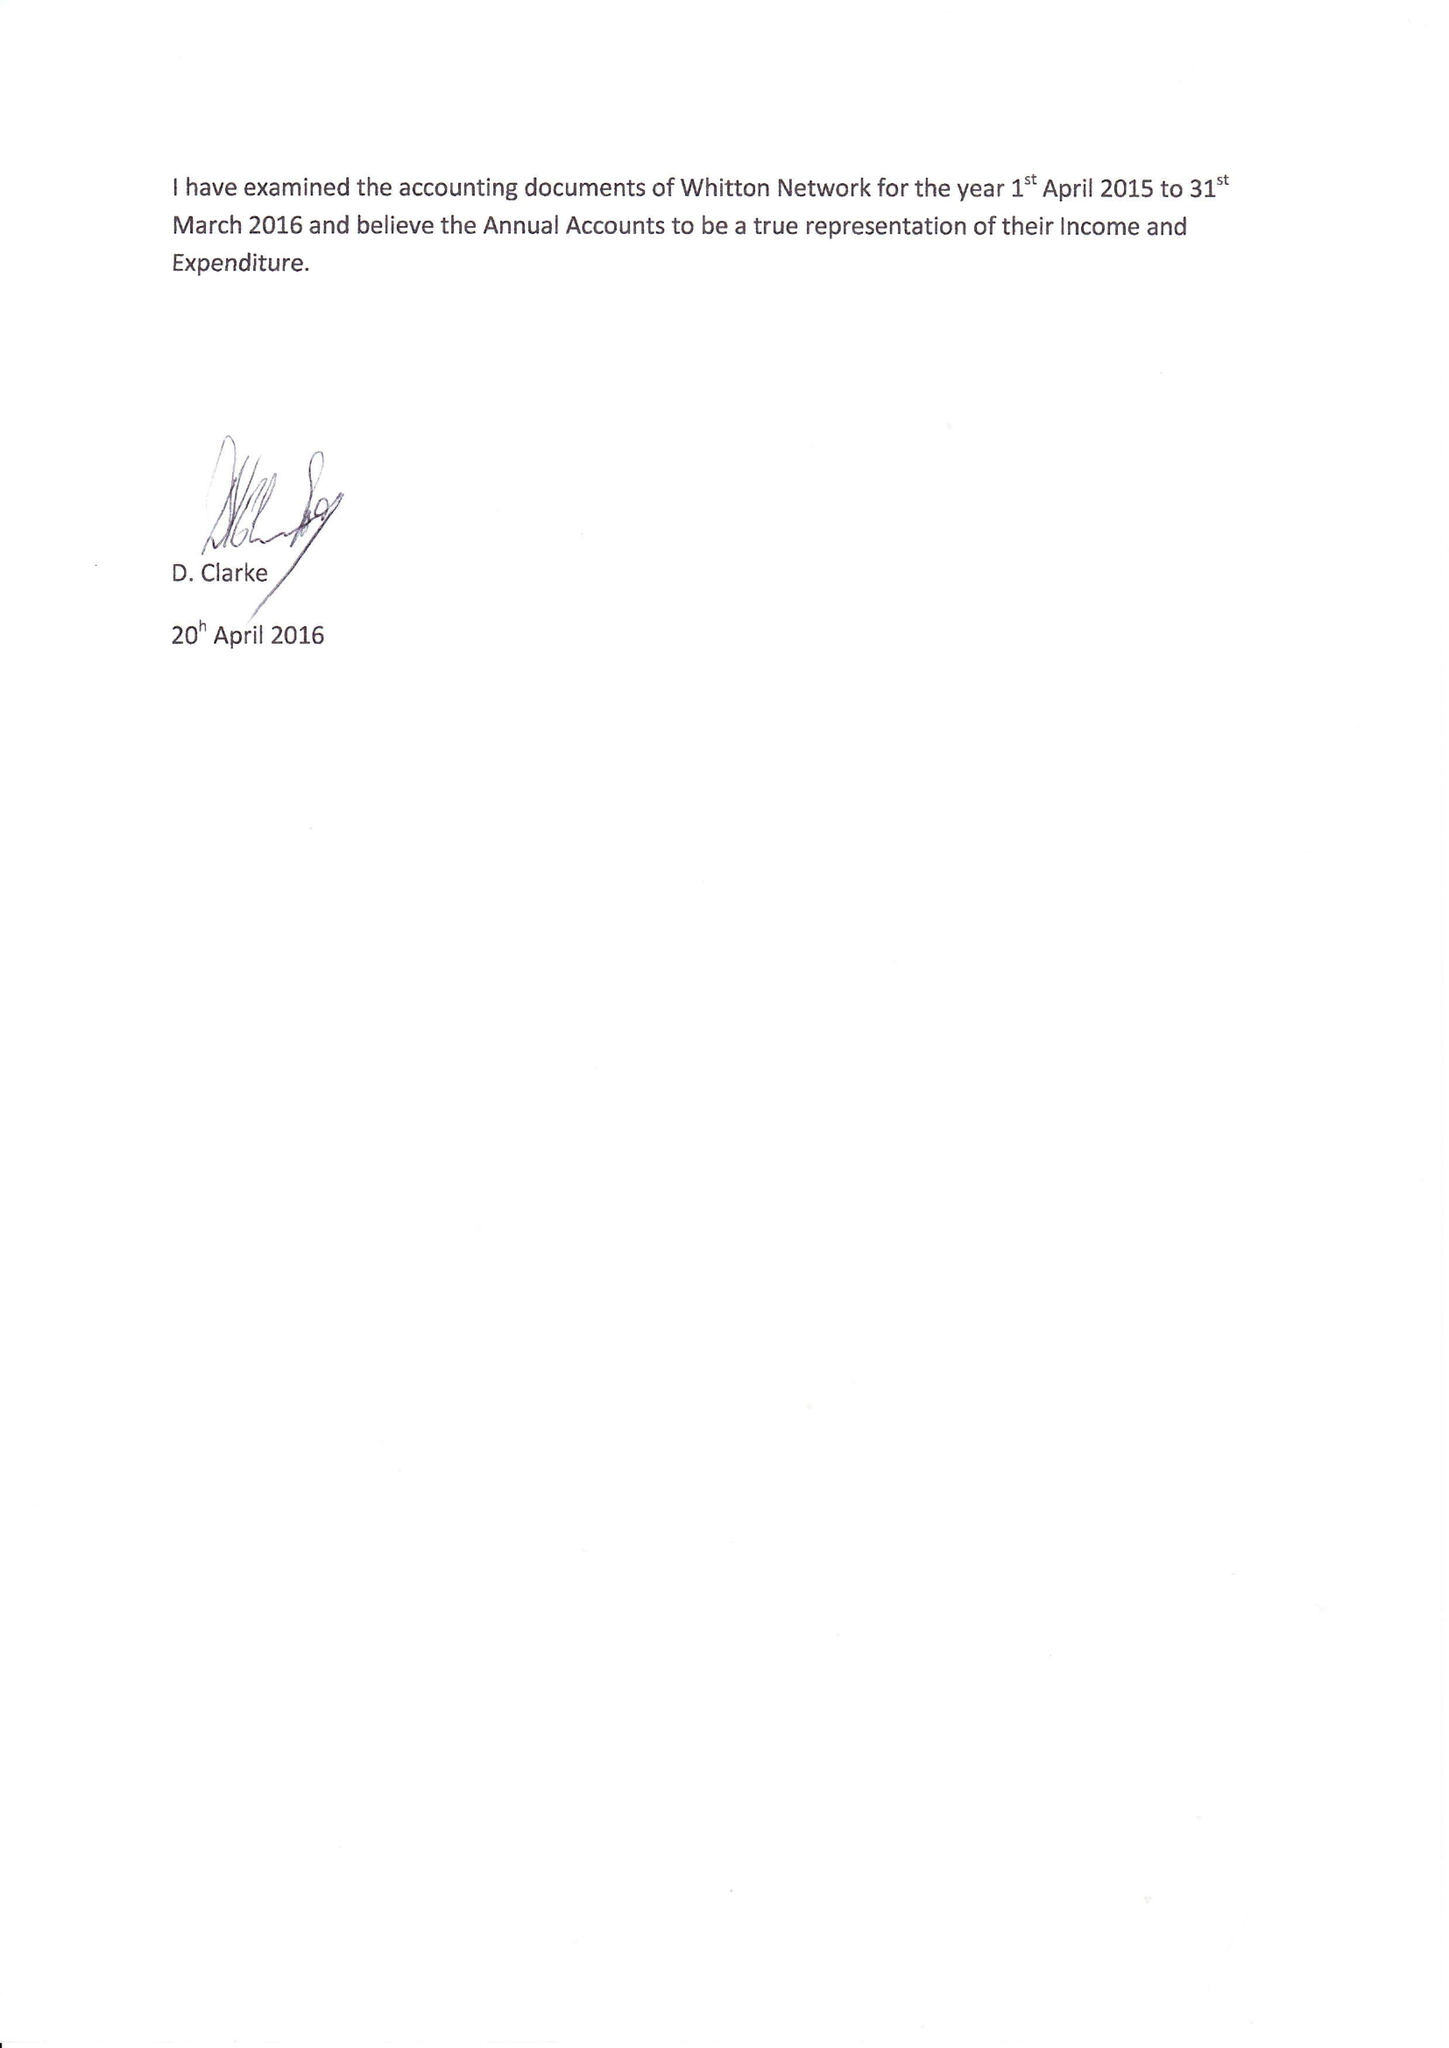What is the value for the address__street_line?
Answer the question using a single word or phrase. 1 LIBRARY WAY 